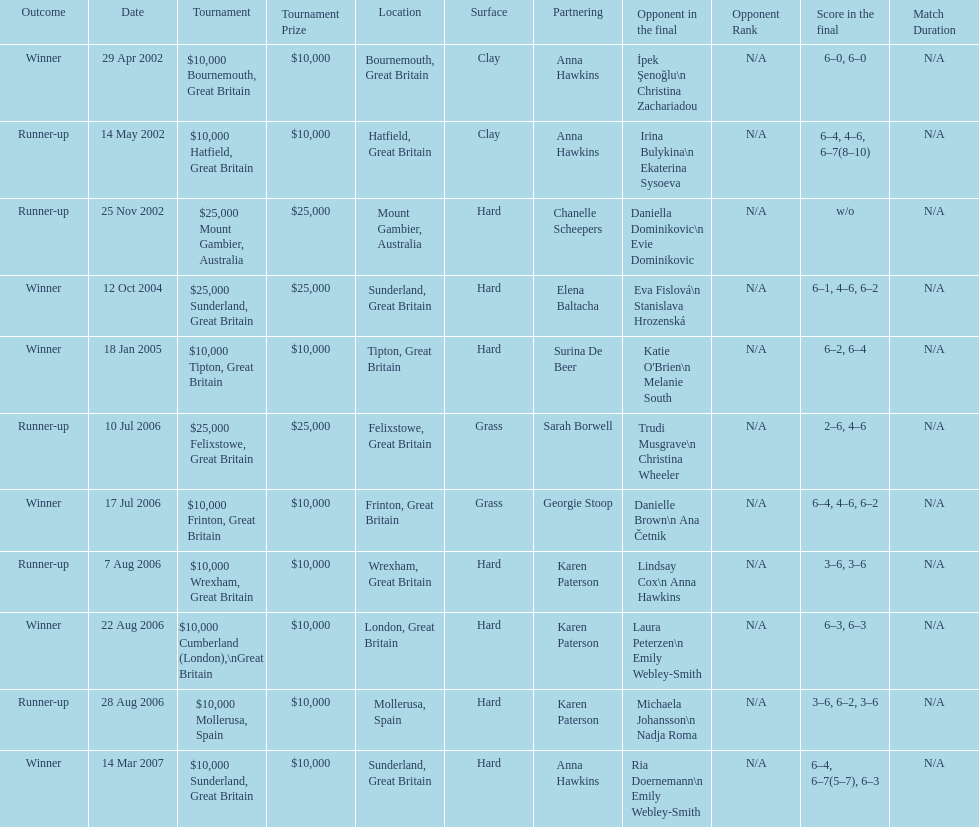What is the number of prize money for the 14 may 2002 tournament? $10,000. 